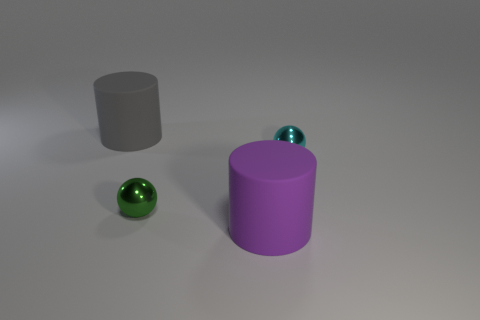Add 4 big metal spheres. How many objects exist? 8 Subtract all gray cylinders. How many cylinders are left? 1 Subtract 1 cylinders. How many cylinders are left? 1 Subtract all gray cylinders. Subtract all blue blocks. How many cylinders are left? 1 Subtract all purple blocks. How many red cylinders are left? 0 Subtract all tiny gray blocks. Subtract all cylinders. How many objects are left? 2 Add 1 cyan balls. How many cyan balls are left? 2 Add 3 gray metallic spheres. How many gray metallic spheres exist? 3 Subtract 0 yellow spheres. How many objects are left? 4 